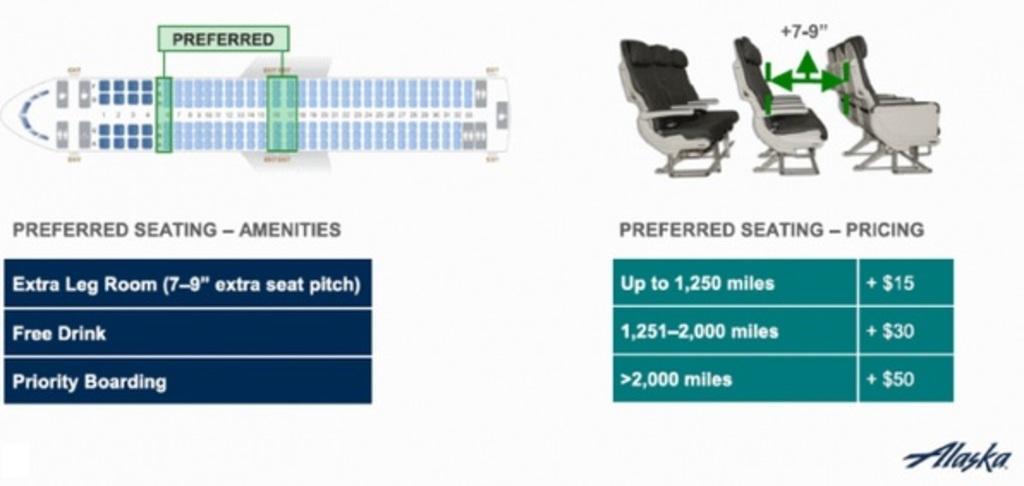Could you give a brief overview of what you see in this image? In the picture we can see a seating arrangement, sheet of the flight with some information and seat diagram. 